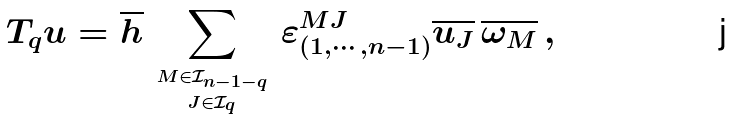Convert formula to latex. <formula><loc_0><loc_0><loc_500><loc_500>T _ { q } u = \overline { h } \, \sum _ { \stackrel { M \in \mathcal { I } _ { n - 1 - q } } { \stackrel { J \in \mathcal { I } _ { q } } { \, } } } \, \varepsilon ^ { M J } _ { ( 1 , \cdots , n - 1 ) } \overline { u _ { J } } \, \overline { \omega _ { M } } \, ,</formula> 